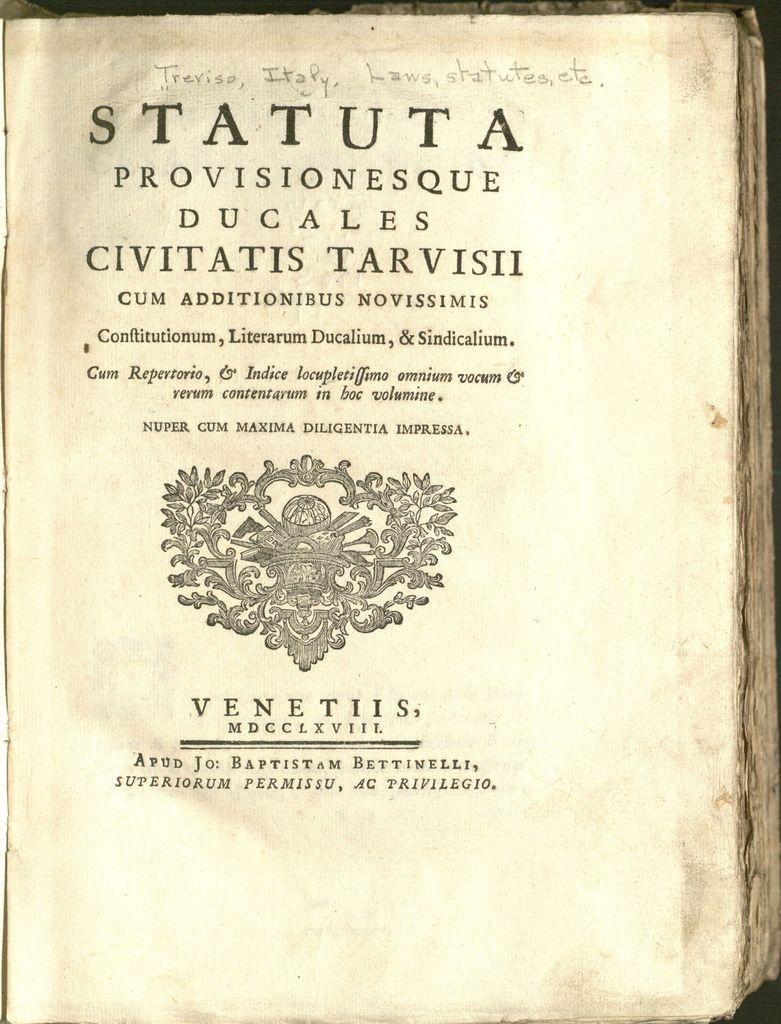Provide a one-sentence caption for the provided image. A book opened to a page reading STATUTA in a different language. 